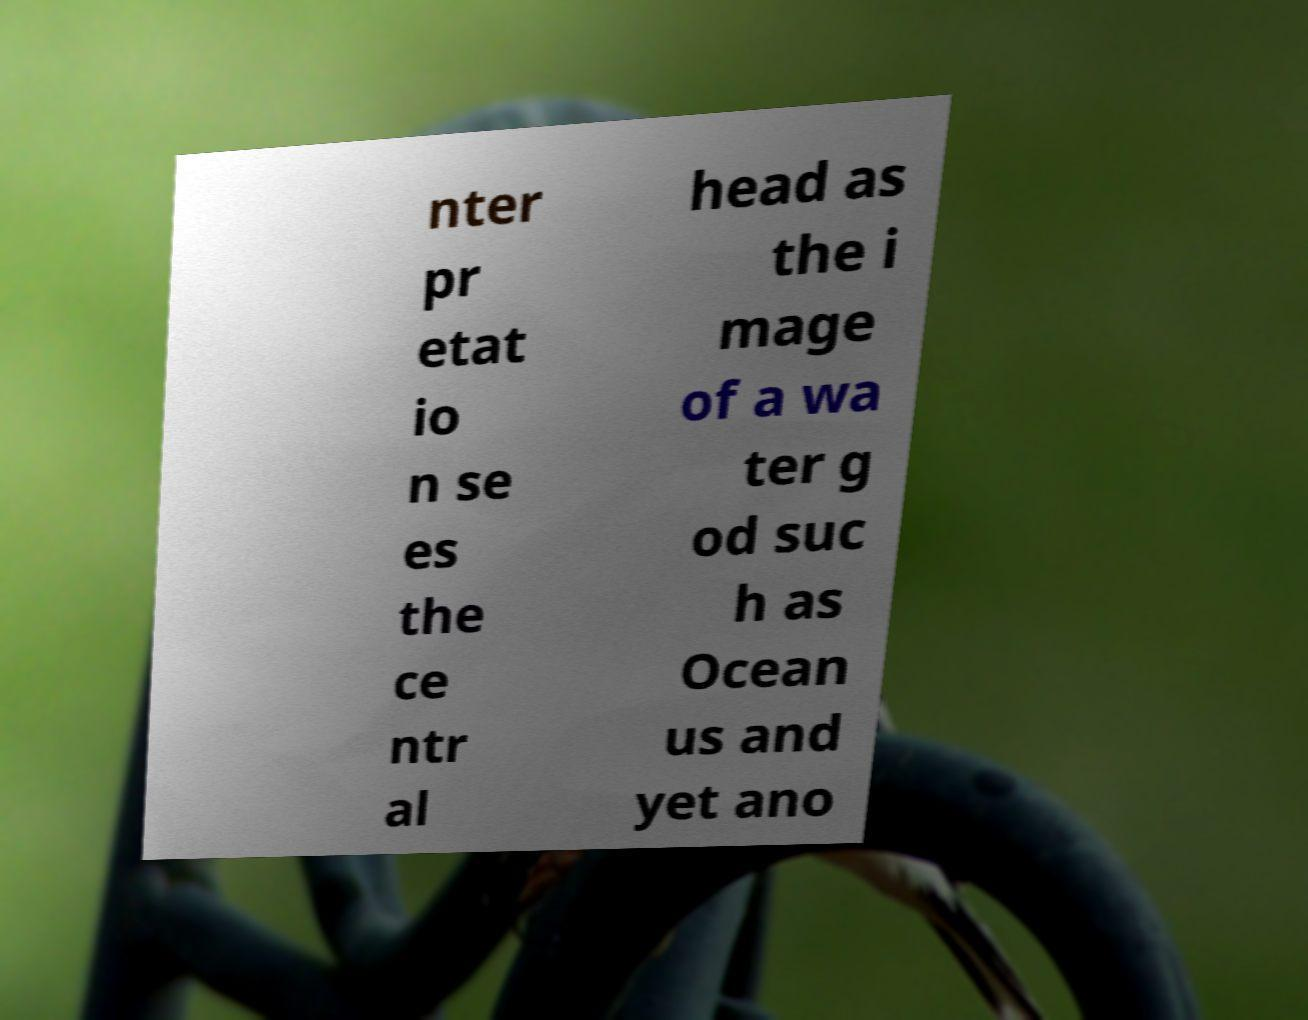Please identify and transcribe the text found in this image. nter pr etat io n se es the ce ntr al head as the i mage of a wa ter g od suc h as Ocean us and yet ano 